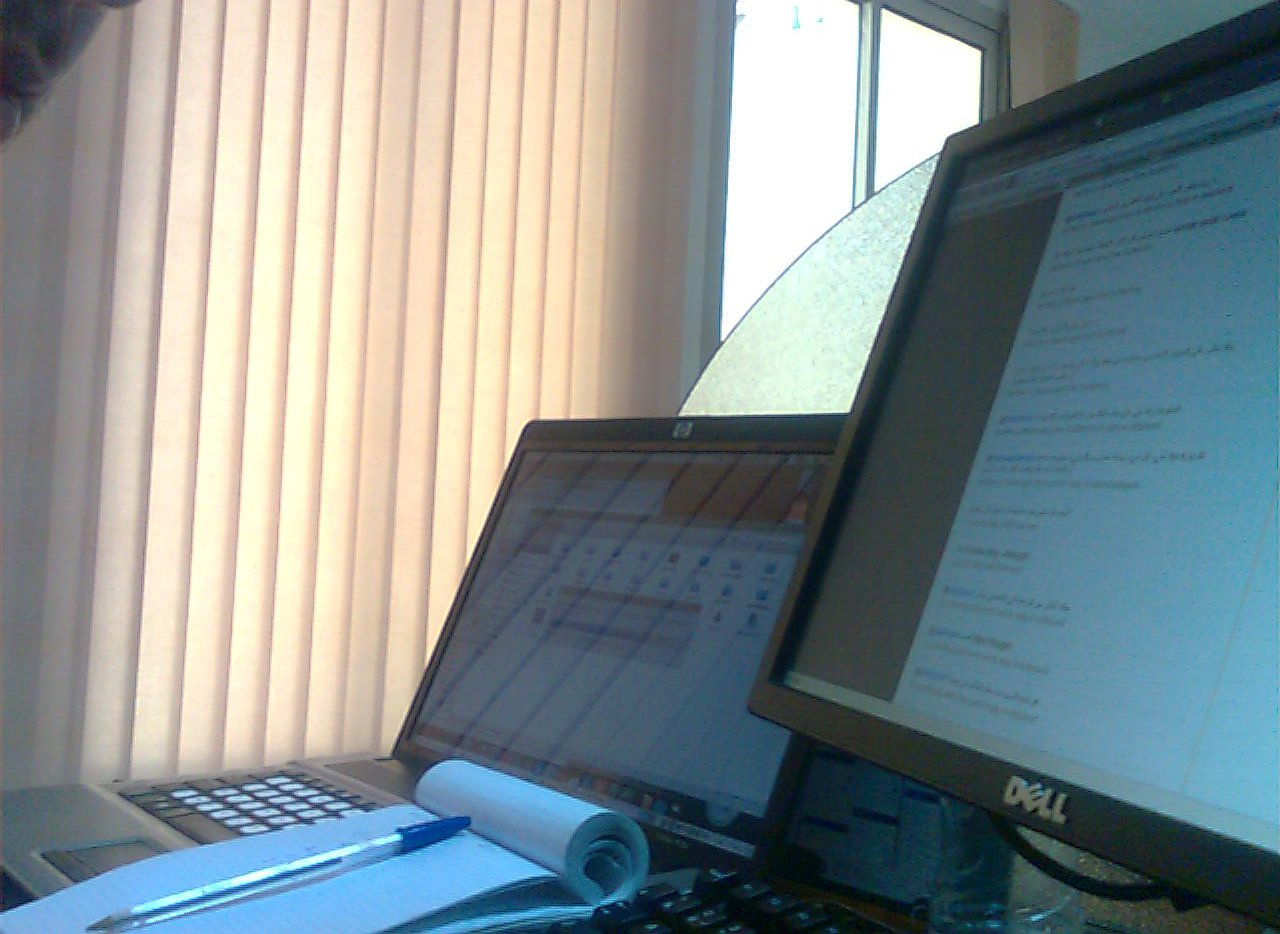Do the blinds look open or closed? The blinds are closed, blocking light effectively and adding privacy to the room. 